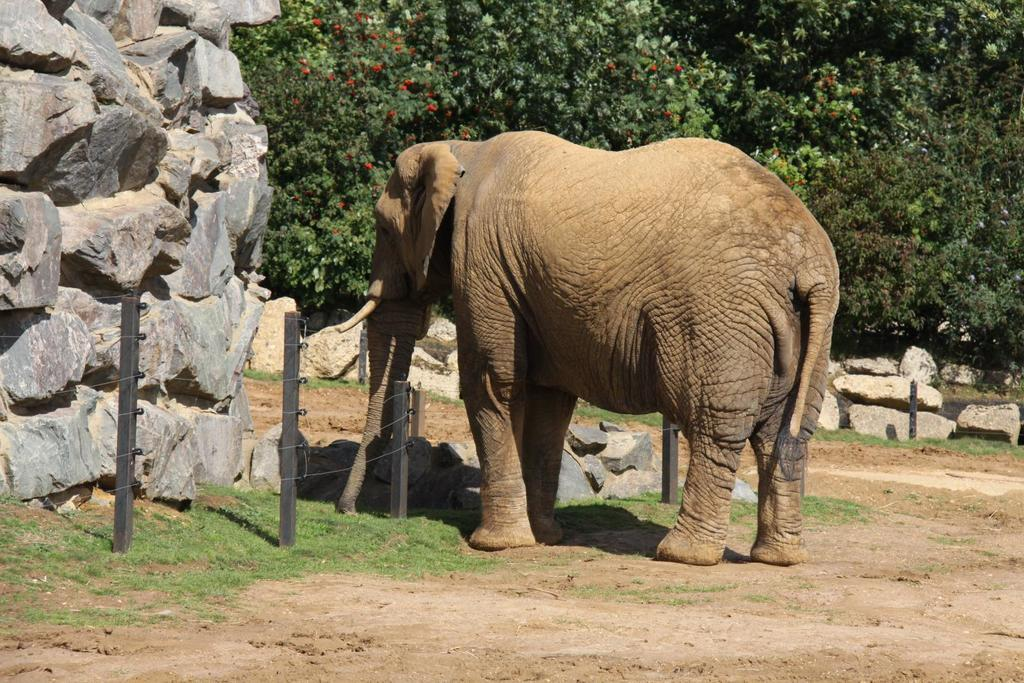What animal is present in the image? There is an elephant in the image. What type of barrier can be seen in the image? There is a fence in the image. What type of natural elements are present in the image? There are stones and grass in the image. What type of vegetation can be seen in the background of the image? There are trees in the background of the image. What type of guitar is the grandmother playing in the image? There is no guitar or grandmother present in the image. 